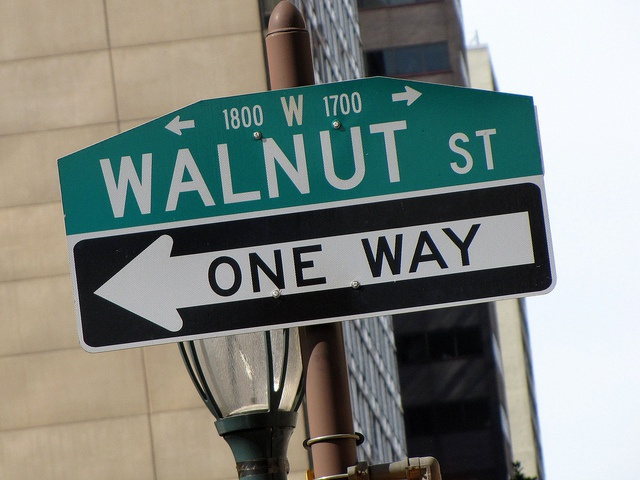Describe the objects in this image and their specific colors. I can see various objects in this image with different colors. 